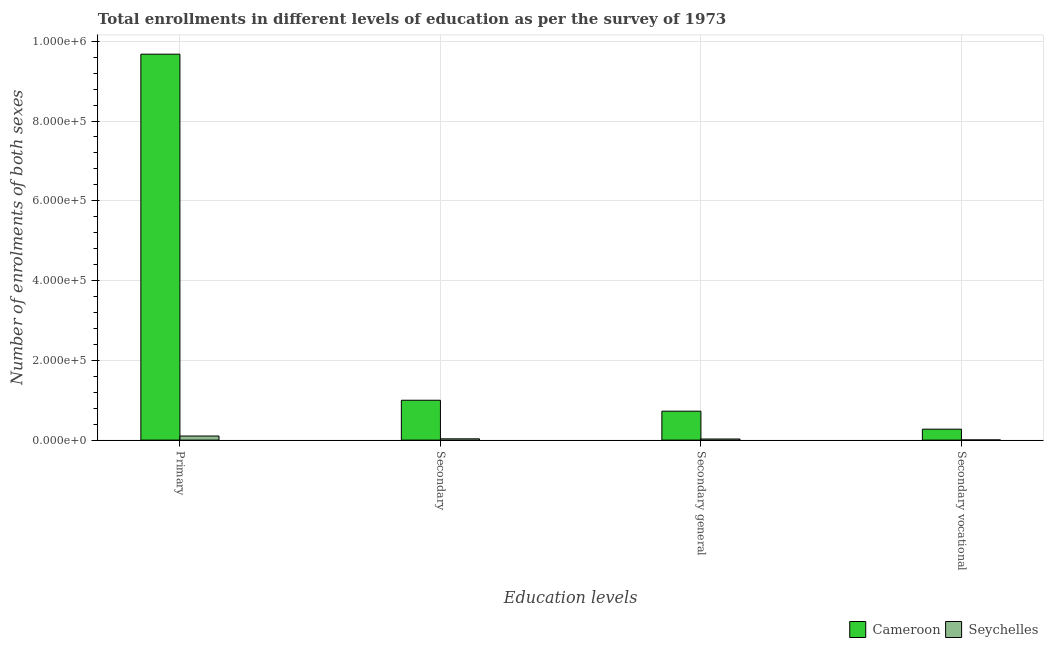How many different coloured bars are there?
Your response must be concise. 2. How many bars are there on the 4th tick from the left?
Provide a succinct answer. 2. What is the label of the 2nd group of bars from the left?
Ensure brevity in your answer.  Secondary. What is the number of enrolments in secondary vocational education in Seychelles?
Your answer should be compact. 418. Across all countries, what is the maximum number of enrolments in secondary vocational education?
Provide a short and direct response. 2.74e+04. Across all countries, what is the minimum number of enrolments in primary education?
Your answer should be compact. 1.03e+04. In which country was the number of enrolments in primary education maximum?
Provide a succinct answer. Cameroon. In which country was the number of enrolments in primary education minimum?
Your answer should be compact. Seychelles. What is the total number of enrolments in primary education in the graph?
Offer a very short reply. 9.78e+05. What is the difference between the number of enrolments in secondary general education in Cameroon and that in Seychelles?
Your response must be concise. 6.98e+04. What is the difference between the number of enrolments in secondary vocational education in Cameroon and the number of enrolments in secondary general education in Seychelles?
Make the answer very short. 2.46e+04. What is the average number of enrolments in secondary vocational education per country?
Ensure brevity in your answer.  1.39e+04. What is the difference between the number of enrolments in secondary education and number of enrolments in secondary general education in Cameroon?
Give a very brief answer. 2.74e+04. What is the ratio of the number of enrolments in secondary vocational education in Seychelles to that in Cameroon?
Your answer should be compact. 0.02. Is the number of enrolments in secondary vocational education in Seychelles less than that in Cameroon?
Keep it short and to the point. Yes. What is the difference between the highest and the second highest number of enrolments in secondary vocational education?
Give a very brief answer. 2.70e+04. What is the difference between the highest and the lowest number of enrolments in secondary vocational education?
Your response must be concise. 2.70e+04. Is it the case that in every country, the sum of the number of enrolments in secondary education and number of enrolments in secondary vocational education is greater than the sum of number of enrolments in primary education and number of enrolments in secondary general education?
Offer a very short reply. No. What does the 2nd bar from the left in Secondary general represents?
Provide a short and direct response. Seychelles. What does the 2nd bar from the right in Primary represents?
Make the answer very short. Cameroon. How many bars are there?
Offer a terse response. 8. Are all the bars in the graph horizontal?
Make the answer very short. No. How many countries are there in the graph?
Provide a succinct answer. 2. Does the graph contain grids?
Your answer should be compact. Yes. How are the legend labels stacked?
Your answer should be compact. Horizontal. What is the title of the graph?
Offer a very short reply. Total enrollments in different levels of education as per the survey of 1973. Does "Zambia" appear as one of the legend labels in the graph?
Give a very brief answer. No. What is the label or title of the X-axis?
Offer a very short reply. Education levels. What is the label or title of the Y-axis?
Ensure brevity in your answer.  Number of enrolments of both sexes. What is the Number of enrolments of both sexes of Cameroon in Primary?
Provide a short and direct response. 9.68e+05. What is the Number of enrolments of both sexes in Seychelles in Primary?
Offer a very short reply. 1.03e+04. What is the Number of enrolments of both sexes of Cameroon in Secondary?
Provide a short and direct response. 1.00e+05. What is the Number of enrolments of both sexes of Seychelles in Secondary?
Keep it short and to the point. 3199. What is the Number of enrolments of both sexes in Cameroon in Secondary general?
Provide a succinct answer. 7.25e+04. What is the Number of enrolments of both sexes of Seychelles in Secondary general?
Offer a very short reply. 2781. What is the Number of enrolments of both sexes in Cameroon in Secondary vocational?
Keep it short and to the point. 2.74e+04. What is the Number of enrolments of both sexes in Seychelles in Secondary vocational?
Your response must be concise. 418. Across all Education levels, what is the maximum Number of enrolments of both sexes in Cameroon?
Offer a terse response. 9.68e+05. Across all Education levels, what is the maximum Number of enrolments of both sexes in Seychelles?
Ensure brevity in your answer.  1.03e+04. Across all Education levels, what is the minimum Number of enrolments of both sexes of Cameroon?
Your answer should be compact. 2.74e+04. Across all Education levels, what is the minimum Number of enrolments of both sexes in Seychelles?
Offer a terse response. 418. What is the total Number of enrolments of both sexes of Cameroon in the graph?
Ensure brevity in your answer.  1.17e+06. What is the total Number of enrolments of both sexes of Seychelles in the graph?
Make the answer very short. 1.67e+04. What is the difference between the Number of enrolments of both sexes of Cameroon in Primary and that in Secondary?
Ensure brevity in your answer.  8.68e+05. What is the difference between the Number of enrolments of both sexes in Seychelles in Primary and that in Secondary?
Your response must be concise. 7076. What is the difference between the Number of enrolments of both sexes of Cameroon in Primary and that in Secondary general?
Your answer should be very brief. 8.95e+05. What is the difference between the Number of enrolments of both sexes of Seychelles in Primary and that in Secondary general?
Keep it short and to the point. 7494. What is the difference between the Number of enrolments of both sexes in Cameroon in Primary and that in Secondary vocational?
Make the answer very short. 9.40e+05. What is the difference between the Number of enrolments of both sexes in Seychelles in Primary and that in Secondary vocational?
Make the answer very short. 9857. What is the difference between the Number of enrolments of both sexes in Cameroon in Secondary and that in Secondary general?
Offer a very short reply. 2.74e+04. What is the difference between the Number of enrolments of both sexes of Seychelles in Secondary and that in Secondary general?
Offer a terse response. 418. What is the difference between the Number of enrolments of both sexes of Cameroon in Secondary and that in Secondary vocational?
Provide a short and direct response. 7.25e+04. What is the difference between the Number of enrolments of both sexes of Seychelles in Secondary and that in Secondary vocational?
Keep it short and to the point. 2781. What is the difference between the Number of enrolments of both sexes in Cameroon in Secondary general and that in Secondary vocational?
Keep it short and to the point. 4.51e+04. What is the difference between the Number of enrolments of both sexes of Seychelles in Secondary general and that in Secondary vocational?
Keep it short and to the point. 2363. What is the difference between the Number of enrolments of both sexes in Cameroon in Primary and the Number of enrolments of both sexes in Seychelles in Secondary?
Your answer should be very brief. 9.64e+05. What is the difference between the Number of enrolments of both sexes in Cameroon in Primary and the Number of enrolments of both sexes in Seychelles in Secondary general?
Make the answer very short. 9.65e+05. What is the difference between the Number of enrolments of both sexes in Cameroon in Primary and the Number of enrolments of both sexes in Seychelles in Secondary vocational?
Your answer should be compact. 9.67e+05. What is the difference between the Number of enrolments of both sexes in Cameroon in Secondary and the Number of enrolments of both sexes in Seychelles in Secondary general?
Your answer should be very brief. 9.72e+04. What is the difference between the Number of enrolments of both sexes of Cameroon in Secondary and the Number of enrolments of both sexes of Seychelles in Secondary vocational?
Offer a very short reply. 9.96e+04. What is the difference between the Number of enrolments of both sexes of Cameroon in Secondary general and the Number of enrolments of both sexes of Seychelles in Secondary vocational?
Offer a terse response. 7.21e+04. What is the average Number of enrolments of both sexes in Cameroon per Education levels?
Provide a succinct answer. 2.92e+05. What is the average Number of enrolments of both sexes in Seychelles per Education levels?
Provide a succinct answer. 4168.25. What is the difference between the Number of enrolments of both sexes in Cameroon and Number of enrolments of both sexes in Seychelles in Primary?
Your answer should be very brief. 9.57e+05. What is the difference between the Number of enrolments of both sexes in Cameroon and Number of enrolments of both sexes in Seychelles in Secondary?
Your answer should be very brief. 9.68e+04. What is the difference between the Number of enrolments of both sexes of Cameroon and Number of enrolments of both sexes of Seychelles in Secondary general?
Your answer should be very brief. 6.98e+04. What is the difference between the Number of enrolments of both sexes in Cameroon and Number of enrolments of both sexes in Seychelles in Secondary vocational?
Your answer should be compact. 2.70e+04. What is the ratio of the Number of enrolments of both sexes in Cameroon in Primary to that in Secondary?
Your answer should be very brief. 9.68. What is the ratio of the Number of enrolments of both sexes in Seychelles in Primary to that in Secondary?
Keep it short and to the point. 3.21. What is the ratio of the Number of enrolments of both sexes of Cameroon in Primary to that in Secondary general?
Provide a succinct answer. 13.34. What is the ratio of the Number of enrolments of both sexes in Seychelles in Primary to that in Secondary general?
Keep it short and to the point. 3.69. What is the ratio of the Number of enrolments of both sexes of Cameroon in Primary to that in Secondary vocational?
Your answer should be compact. 35.27. What is the ratio of the Number of enrolments of both sexes of Seychelles in Primary to that in Secondary vocational?
Make the answer very short. 24.58. What is the ratio of the Number of enrolments of both sexes of Cameroon in Secondary to that in Secondary general?
Your response must be concise. 1.38. What is the ratio of the Number of enrolments of both sexes of Seychelles in Secondary to that in Secondary general?
Make the answer very short. 1.15. What is the ratio of the Number of enrolments of both sexes of Cameroon in Secondary to that in Secondary vocational?
Offer a terse response. 3.64. What is the ratio of the Number of enrolments of both sexes of Seychelles in Secondary to that in Secondary vocational?
Provide a short and direct response. 7.65. What is the ratio of the Number of enrolments of both sexes of Cameroon in Secondary general to that in Secondary vocational?
Make the answer very short. 2.64. What is the ratio of the Number of enrolments of both sexes in Seychelles in Secondary general to that in Secondary vocational?
Your answer should be very brief. 6.65. What is the difference between the highest and the second highest Number of enrolments of both sexes of Cameroon?
Provide a succinct answer. 8.68e+05. What is the difference between the highest and the second highest Number of enrolments of both sexes in Seychelles?
Provide a short and direct response. 7076. What is the difference between the highest and the lowest Number of enrolments of both sexes of Cameroon?
Offer a terse response. 9.40e+05. What is the difference between the highest and the lowest Number of enrolments of both sexes of Seychelles?
Offer a very short reply. 9857. 